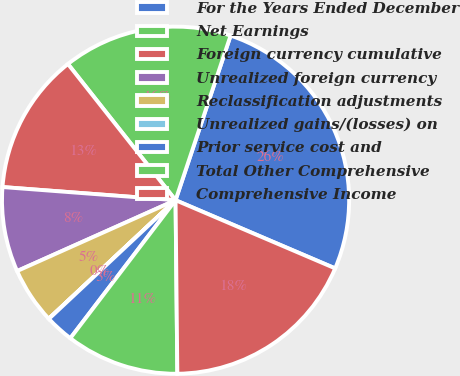<chart> <loc_0><loc_0><loc_500><loc_500><pie_chart><fcel>For the Years Ended December<fcel>Net Earnings<fcel>Foreign currency cumulative<fcel>Unrealized foreign currency<fcel>Reclassification adjustments<fcel>Unrealized gains/(losses) on<fcel>Prior service cost and<fcel>Total Other Comprehensive<fcel>Comprehensive Income<nl><fcel>26.29%<fcel>15.78%<fcel>13.15%<fcel>7.9%<fcel>5.27%<fcel>0.02%<fcel>2.65%<fcel>10.53%<fcel>18.41%<nl></chart> 